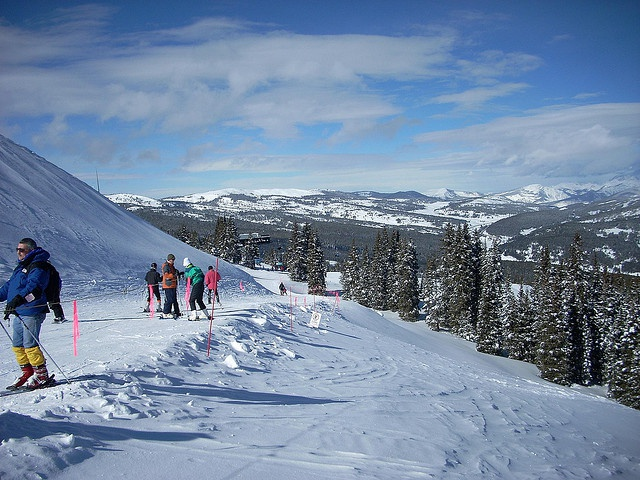Describe the objects in this image and their specific colors. I can see people in navy, black, blue, and gray tones, people in navy, black, gray, and maroon tones, people in navy, black, white, teal, and gray tones, people in navy, black, gray, and darkgray tones, and people in navy, black, gray, and darkgray tones in this image. 